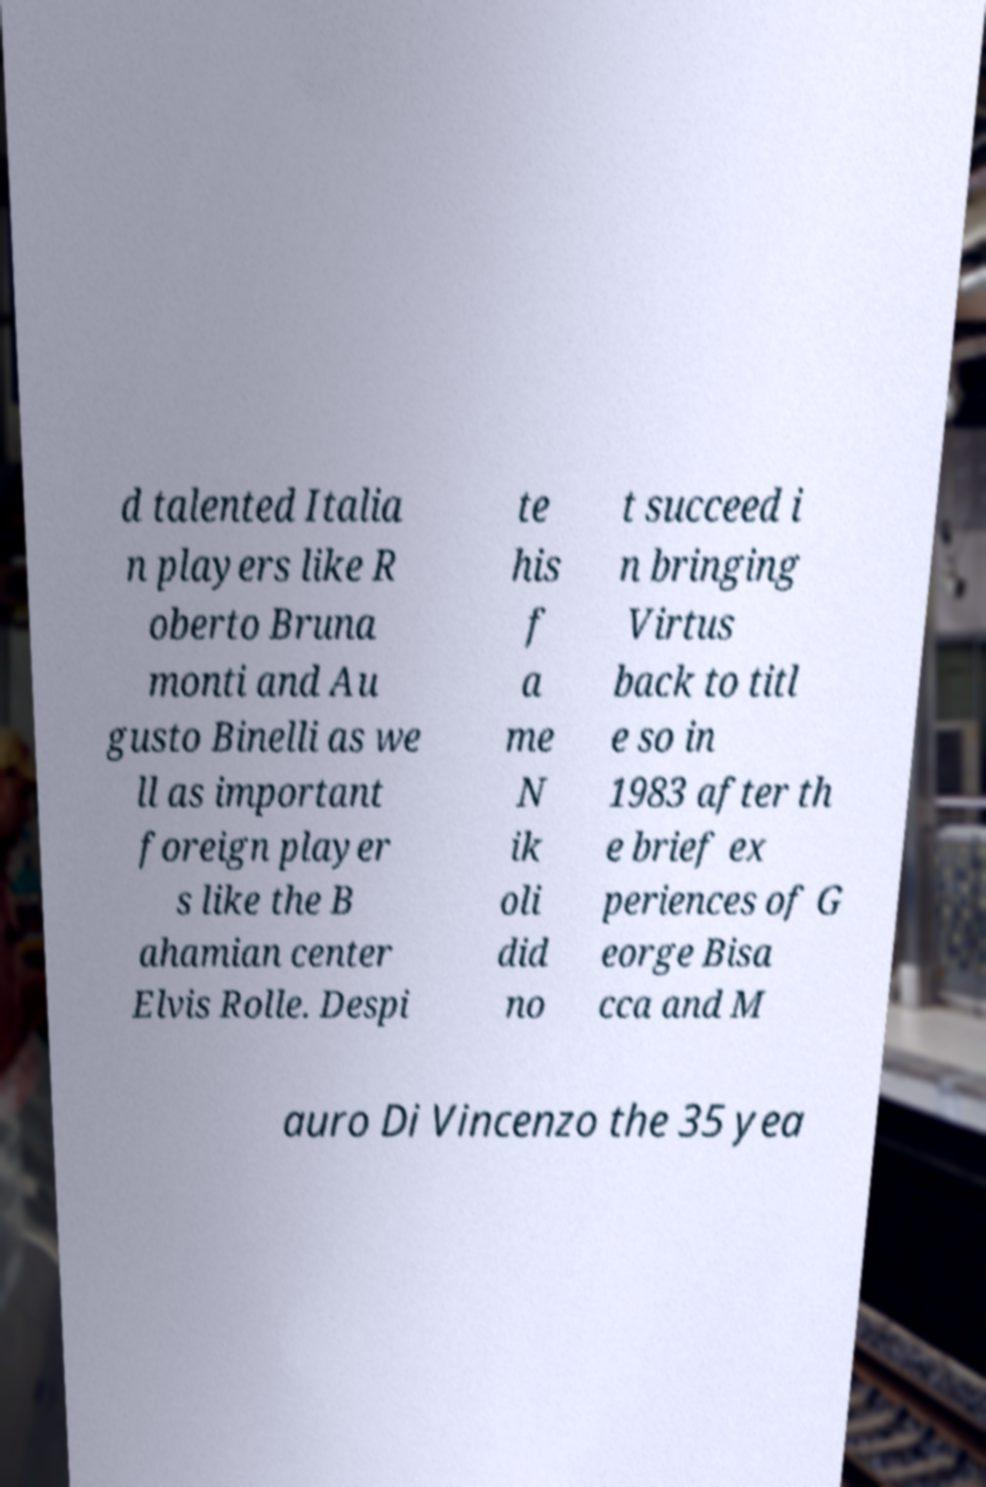For documentation purposes, I need the text within this image transcribed. Could you provide that? d talented Italia n players like R oberto Bruna monti and Au gusto Binelli as we ll as important foreign player s like the B ahamian center Elvis Rolle. Despi te his f a me N ik oli did no t succeed i n bringing Virtus back to titl e so in 1983 after th e brief ex periences of G eorge Bisa cca and M auro Di Vincenzo the 35 yea 